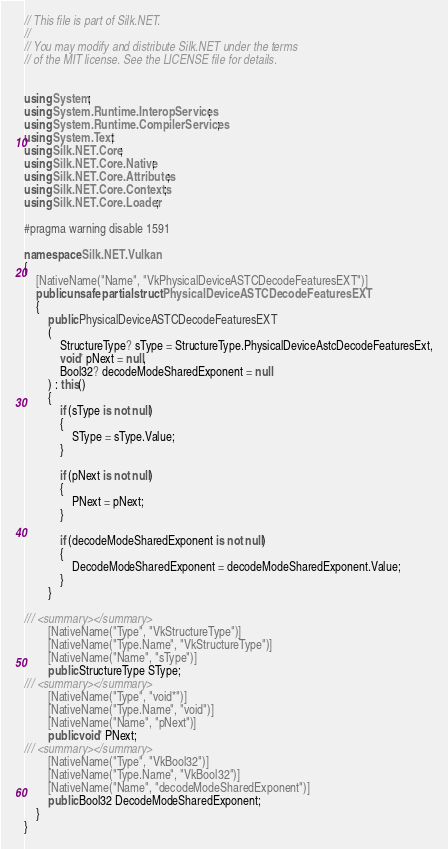<code> <loc_0><loc_0><loc_500><loc_500><_C#_>// This file is part of Silk.NET.
// 
// You may modify and distribute Silk.NET under the terms
// of the MIT license. See the LICENSE file for details.


using System;
using System.Runtime.InteropServices;
using System.Runtime.CompilerServices;
using System.Text;
using Silk.NET.Core;
using Silk.NET.Core.Native;
using Silk.NET.Core.Attributes;
using Silk.NET.Core.Contexts;
using Silk.NET.Core.Loader;

#pragma warning disable 1591

namespace Silk.NET.Vulkan
{
    [NativeName("Name", "VkPhysicalDeviceASTCDecodeFeaturesEXT")]
    public unsafe partial struct PhysicalDeviceASTCDecodeFeaturesEXT
    {
        public PhysicalDeviceASTCDecodeFeaturesEXT
        (
            StructureType? sType = StructureType.PhysicalDeviceAstcDecodeFeaturesExt,
            void* pNext = null,
            Bool32? decodeModeSharedExponent = null
        ) : this()
        {
            if (sType is not null)
            {
                SType = sType.Value;
            }

            if (pNext is not null)
            {
                PNext = pNext;
            }

            if (decodeModeSharedExponent is not null)
            {
                DecodeModeSharedExponent = decodeModeSharedExponent.Value;
            }
        }

/// <summary></summary>
        [NativeName("Type", "VkStructureType")]
        [NativeName("Type.Name", "VkStructureType")]
        [NativeName("Name", "sType")]
        public StructureType SType;
/// <summary></summary>
        [NativeName("Type", "void*")]
        [NativeName("Type.Name", "void")]
        [NativeName("Name", "pNext")]
        public void* PNext;
/// <summary></summary>
        [NativeName("Type", "VkBool32")]
        [NativeName("Type.Name", "VkBool32")]
        [NativeName("Name", "decodeModeSharedExponent")]
        public Bool32 DecodeModeSharedExponent;
    }
}
</code> 